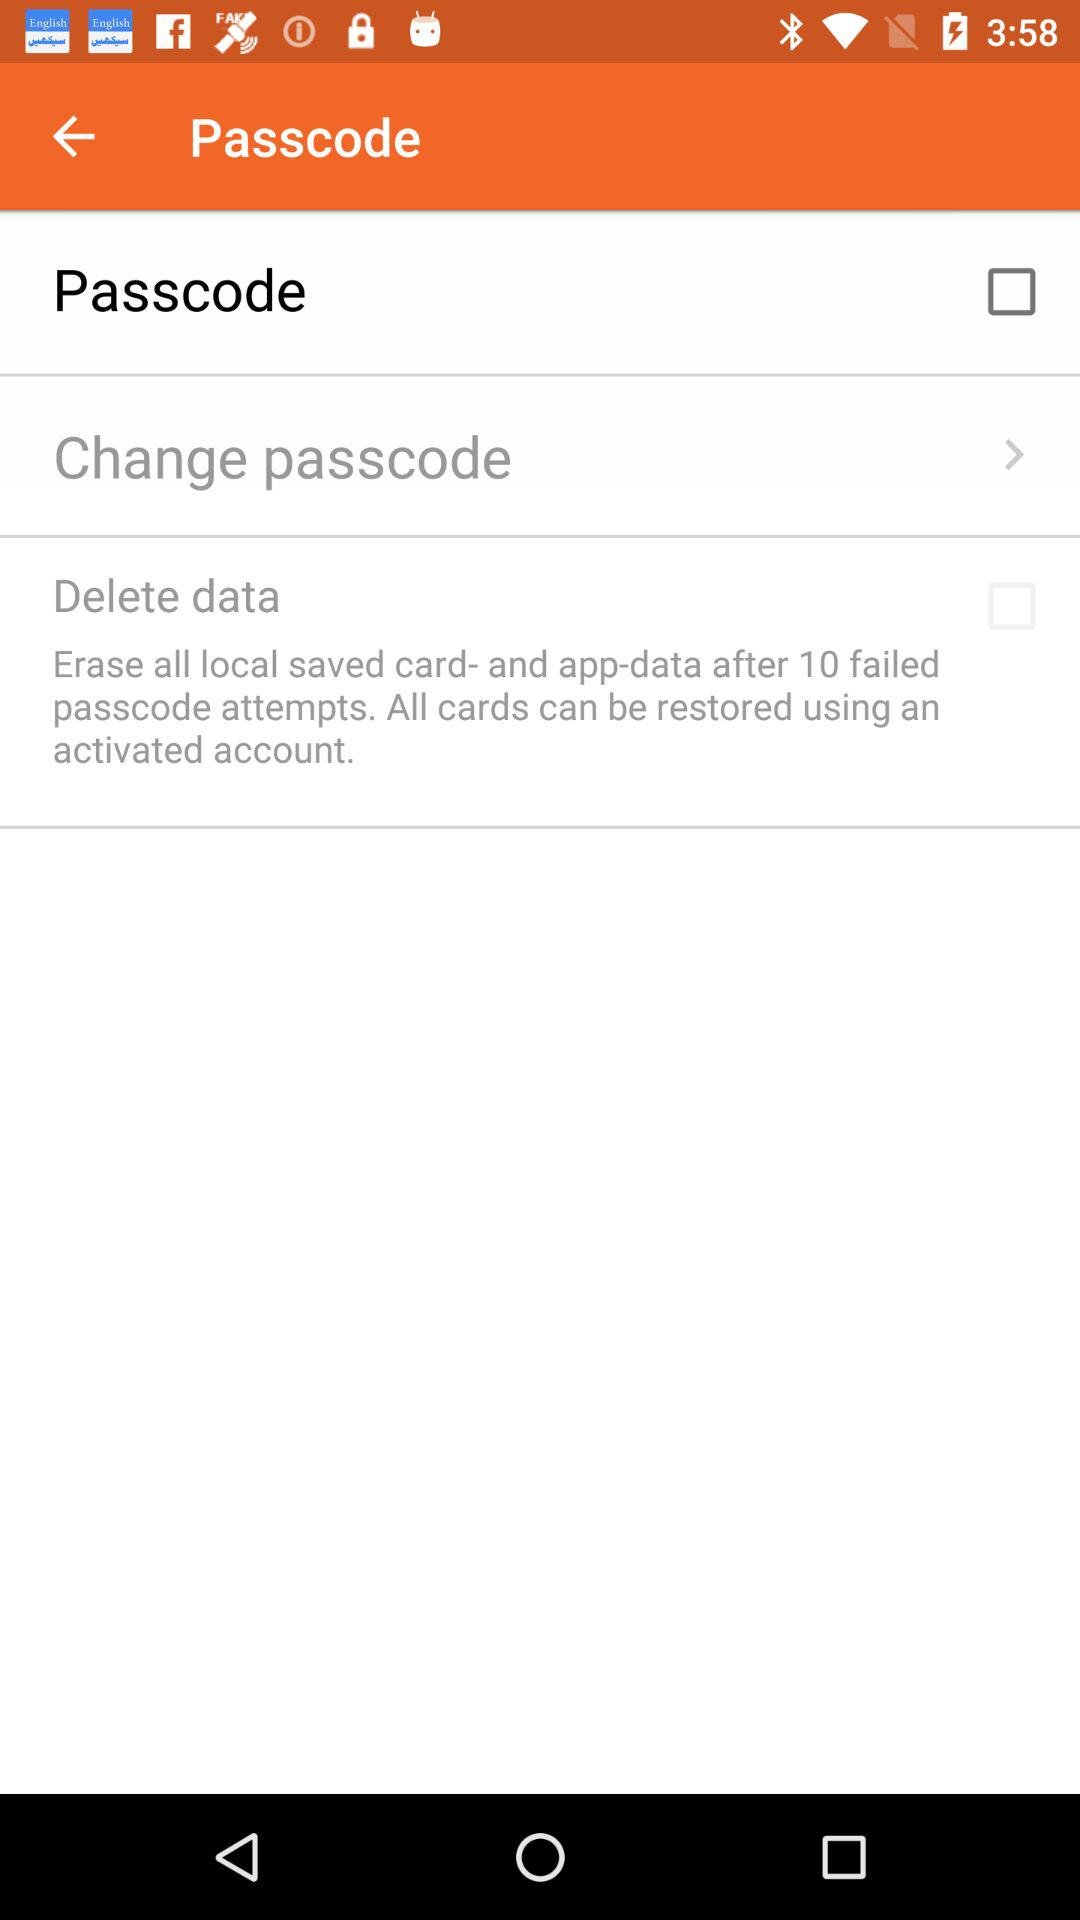What is the status of the "Passcode"? The status of the "Passcode" is "off". 